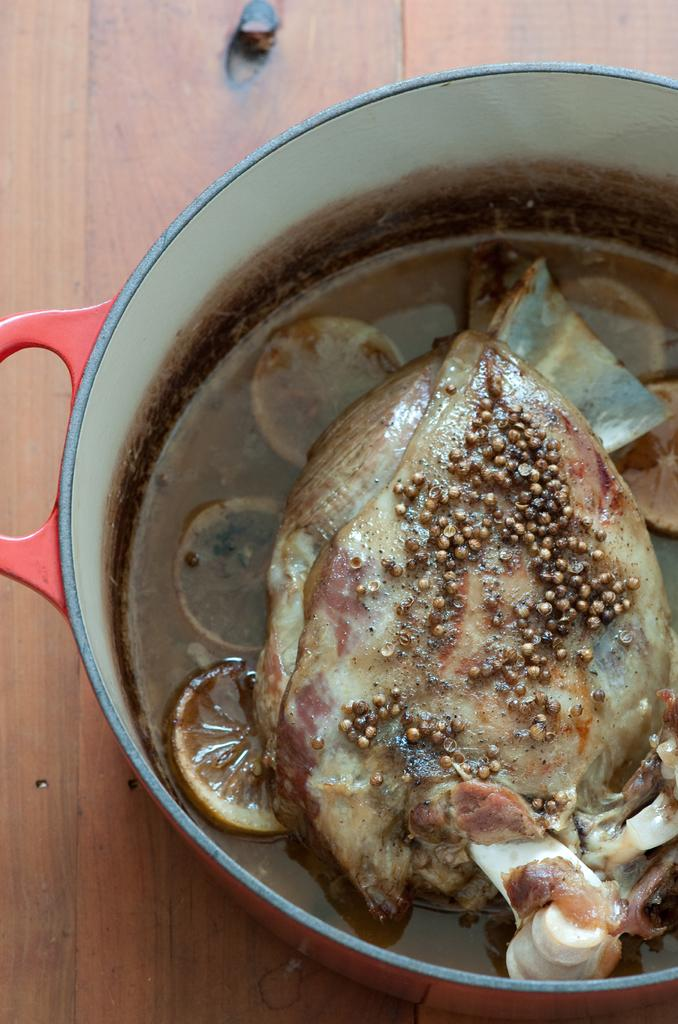What object in the image is used for eating or serving food? There is a utensil in the image that is used for eating or serving food. What type of food is in the utensil? The food appears to be fish. On what surface is the utensil placed? The utensil is utensil is placed on a wooden board. What type of linen is draped over the fish in the image? There is no linen draped over the fish in the image; it only shows a utensil filled with fish placed on a wooden board. 